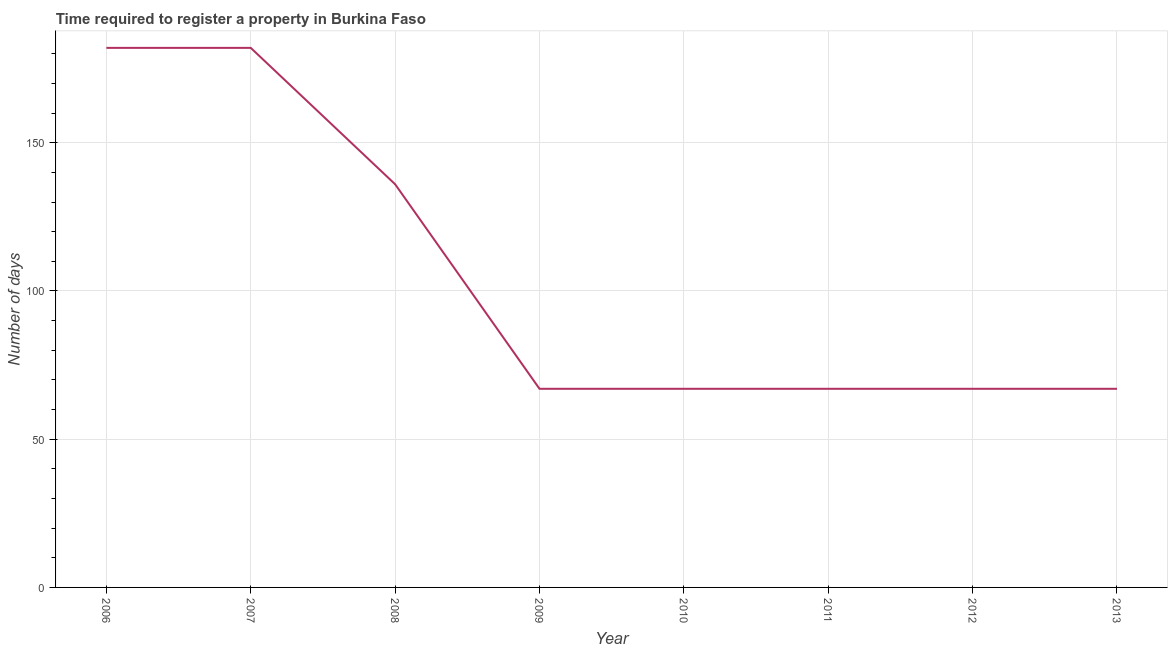What is the number of days required to register property in 2006?
Offer a terse response. 182. Across all years, what is the maximum number of days required to register property?
Offer a terse response. 182. Across all years, what is the minimum number of days required to register property?
Provide a short and direct response. 67. In which year was the number of days required to register property maximum?
Offer a very short reply. 2006. In which year was the number of days required to register property minimum?
Provide a short and direct response. 2009. What is the sum of the number of days required to register property?
Provide a short and direct response. 835. What is the average number of days required to register property per year?
Your answer should be very brief. 104.38. In how many years, is the number of days required to register property greater than 150 days?
Provide a short and direct response. 2. What is the ratio of the number of days required to register property in 2006 to that in 2010?
Keep it short and to the point. 2.72. Is the number of days required to register property in 2007 less than that in 2012?
Provide a succinct answer. No. What is the difference between the highest and the second highest number of days required to register property?
Provide a short and direct response. 0. Is the sum of the number of days required to register property in 2006 and 2013 greater than the maximum number of days required to register property across all years?
Your response must be concise. Yes. What is the difference between the highest and the lowest number of days required to register property?
Ensure brevity in your answer.  115. In how many years, is the number of days required to register property greater than the average number of days required to register property taken over all years?
Provide a short and direct response. 3. Are the values on the major ticks of Y-axis written in scientific E-notation?
Your answer should be compact. No. Does the graph contain any zero values?
Provide a short and direct response. No. Does the graph contain grids?
Give a very brief answer. Yes. What is the title of the graph?
Your answer should be very brief. Time required to register a property in Burkina Faso. What is the label or title of the X-axis?
Your answer should be compact. Year. What is the label or title of the Y-axis?
Make the answer very short. Number of days. What is the Number of days of 2006?
Make the answer very short. 182. What is the Number of days of 2007?
Provide a succinct answer. 182. What is the Number of days of 2008?
Your answer should be very brief. 136. What is the Number of days of 2009?
Provide a succinct answer. 67. What is the Number of days in 2010?
Offer a terse response. 67. What is the Number of days of 2011?
Offer a very short reply. 67. What is the Number of days of 2012?
Your answer should be very brief. 67. What is the Number of days in 2013?
Offer a terse response. 67. What is the difference between the Number of days in 2006 and 2007?
Offer a very short reply. 0. What is the difference between the Number of days in 2006 and 2009?
Provide a short and direct response. 115. What is the difference between the Number of days in 2006 and 2010?
Provide a succinct answer. 115. What is the difference between the Number of days in 2006 and 2011?
Keep it short and to the point. 115. What is the difference between the Number of days in 2006 and 2012?
Provide a short and direct response. 115. What is the difference between the Number of days in 2006 and 2013?
Provide a short and direct response. 115. What is the difference between the Number of days in 2007 and 2009?
Provide a succinct answer. 115. What is the difference between the Number of days in 2007 and 2010?
Your answer should be compact. 115. What is the difference between the Number of days in 2007 and 2011?
Your response must be concise. 115. What is the difference between the Number of days in 2007 and 2012?
Your response must be concise. 115. What is the difference between the Number of days in 2007 and 2013?
Provide a short and direct response. 115. What is the difference between the Number of days in 2008 and 2009?
Provide a succinct answer. 69. What is the difference between the Number of days in 2008 and 2011?
Provide a short and direct response. 69. What is the difference between the Number of days in 2008 and 2012?
Provide a succinct answer. 69. What is the difference between the Number of days in 2009 and 2011?
Your answer should be very brief. 0. What is the difference between the Number of days in 2009 and 2012?
Your response must be concise. 0. What is the difference between the Number of days in 2009 and 2013?
Ensure brevity in your answer.  0. What is the difference between the Number of days in 2010 and 2013?
Provide a short and direct response. 0. What is the ratio of the Number of days in 2006 to that in 2008?
Your answer should be compact. 1.34. What is the ratio of the Number of days in 2006 to that in 2009?
Ensure brevity in your answer.  2.72. What is the ratio of the Number of days in 2006 to that in 2010?
Give a very brief answer. 2.72. What is the ratio of the Number of days in 2006 to that in 2011?
Offer a terse response. 2.72. What is the ratio of the Number of days in 2006 to that in 2012?
Your answer should be compact. 2.72. What is the ratio of the Number of days in 2006 to that in 2013?
Provide a short and direct response. 2.72. What is the ratio of the Number of days in 2007 to that in 2008?
Your answer should be very brief. 1.34. What is the ratio of the Number of days in 2007 to that in 2009?
Give a very brief answer. 2.72. What is the ratio of the Number of days in 2007 to that in 2010?
Keep it short and to the point. 2.72. What is the ratio of the Number of days in 2007 to that in 2011?
Your response must be concise. 2.72. What is the ratio of the Number of days in 2007 to that in 2012?
Your answer should be very brief. 2.72. What is the ratio of the Number of days in 2007 to that in 2013?
Your answer should be very brief. 2.72. What is the ratio of the Number of days in 2008 to that in 2009?
Your answer should be very brief. 2.03. What is the ratio of the Number of days in 2008 to that in 2010?
Provide a succinct answer. 2.03. What is the ratio of the Number of days in 2008 to that in 2011?
Your response must be concise. 2.03. What is the ratio of the Number of days in 2008 to that in 2012?
Your answer should be very brief. 2.03. What is the ratio of the Number of days in 2008 to that in 2013?
Offer a terse response. 2.03. What is the ratio of the Number of days in 2009 to that in 2011?
Your answer should be compact. 1. What is the ratio of the Number of days in 2009 to that in 2012?
Ensure brevity in your answer.  1. What is the ratio of the Number of days in 2009 to that in 2013?
Keep it short and to the point. 1. What is the ratio of the Number of days in 2010 to that in 2011?
Keep it short and to the point. 1. What is the ratio of the Number of days in 2010 to that in 2013?
Your answer should be compact. 1. 